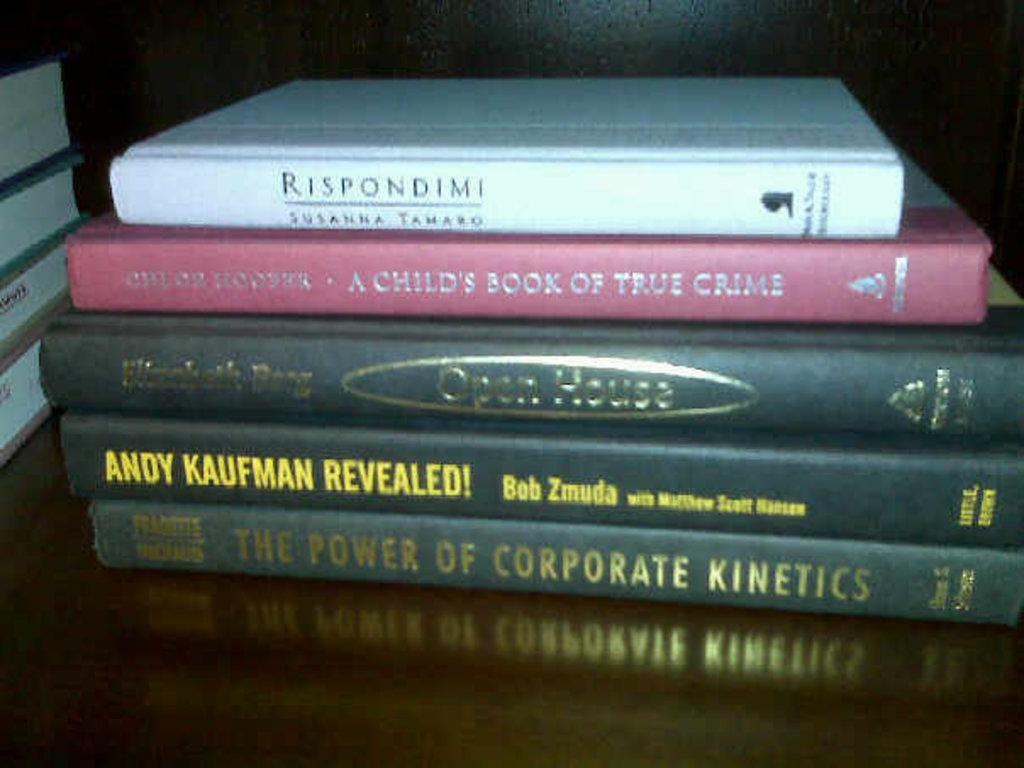What age group is the red book for?
Offer a terse response. Child. What is the title of the white book?
Keep it short and to the point. Rispondimi. 